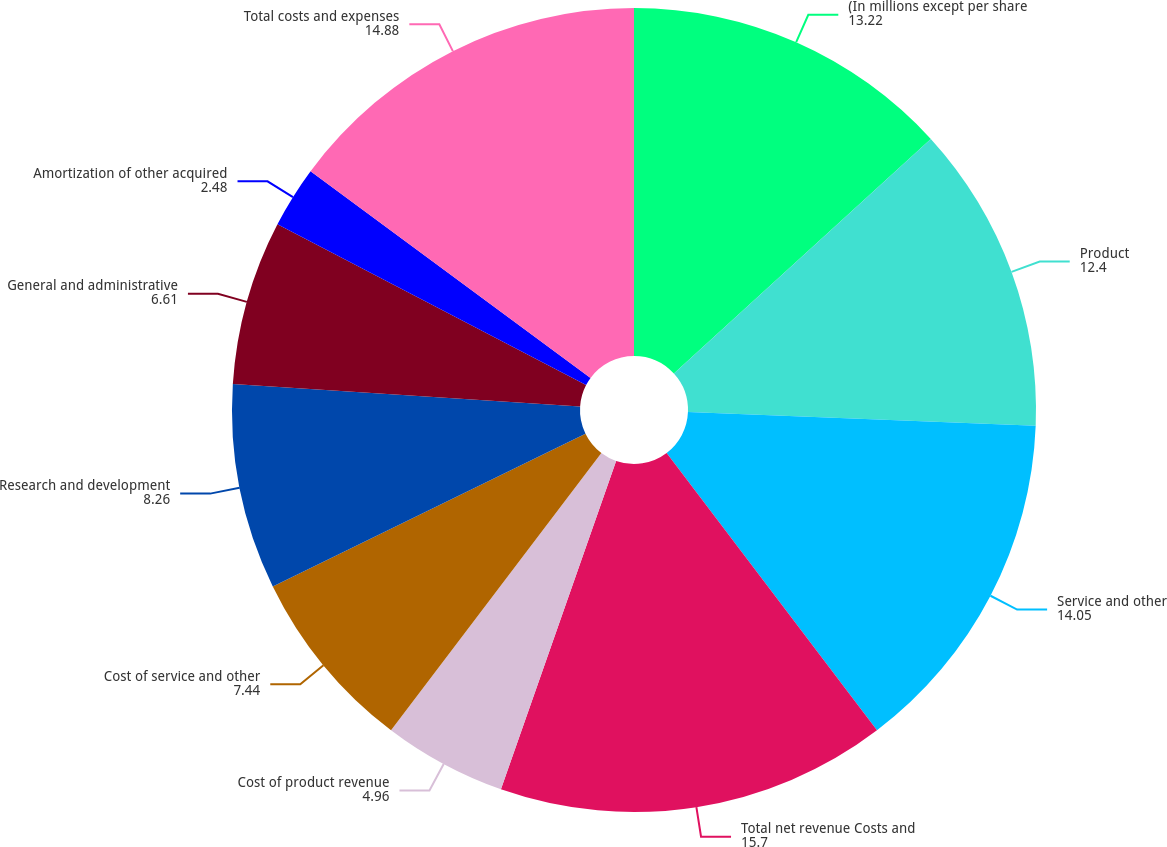Convert chart to OTSL. <chart><loc_0><loc_0><loc_500><loc_500><pie_chart><fcel>(In millions except per share<fcel>Product<fcel>Service and other<fcel>Total net revenue Costs and<fcel>Cost of product revenue<fcel>Cost of service and other<fcel>Research and development<fcel>General and administrative<fcel>Amortization of other acquired<fcel>Total costs and expenses<nl><fcel>13.22%<fcel>12.4%<fcel>14.05%<fcel>15.7%<fcel>4.96%<fcel>7.44%<fcel>8.26%<fcel>6.61%<fcel>2.48%<fcel>14.88%<nl></chart> 